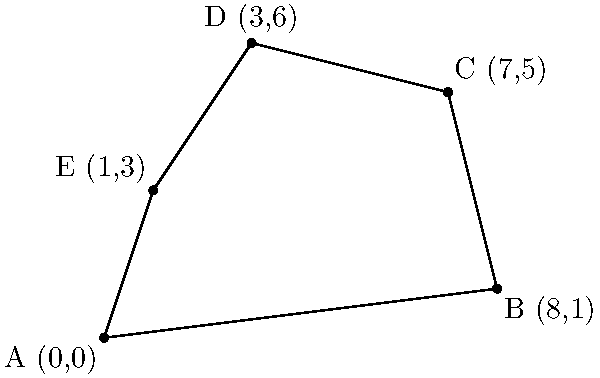As a retail manager overseeing multiple store locations, you've plotted five key stores on a coordinate map to analyze your sales region. The stores are located at A(0,0), B(8,1), C(7,5), D(3,6), and E(1,3). Calculate the area of the polygonal sales region formed by connecting these store locations. Round your answer to the nearest whole number. To find the area of this irregular polygon, we can use the Shoelace formula (also known as the surveyor's formula). The steps are as follows:

1) The Shoelace formula for a polygon with vertices $(x_1, y_1), (x_2, y_2), ..., (x_n, y_n)$ is:

   Area = $\frac{1}{2}|((x_1y_2 + x_2y_3 + ... + x_ny_1) - (y_1x_2 + y_2x_3 + ... + y_nx_1))|$

2) Substituting our coordinates:
   A(0,0), B(8,1), C(7,5), D(3,6), E(1,3)

3) Applying the formula:

   Area = $\frac{1}{2}|((0 \cdot 1 + 8 \cdot 5 + 7 \cdot 6 + 3 \cdot 3 + 1 \cdot 0) - (0 \cdot 8 + 1 \cdot 7 + 5 \cdot 3 + 6 \cdot 1 + 3 \cdot 0))|$

4) Simplifying:
   
   Area = $\frac{1}{2}|((0 + 40 + 42 + 9 + 0) - (0 + 7 + 15 + 6 + 0))|$
   
   Area = $\frac{1}{2}|(91 - 28)|$
   
   Area = $\frac{1}{2}(63)$
   
   Area = 31.5

5) Rounding to the nearest whole number:

   Area ≈ 32

Therefore, the area of the polygonal sales region is approximately 32 square units.
Answer: 32 square units 